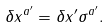Convert formula to latex. <formula><loc_0><loc_0><loc_500><loc_500>\delta x ^ { a ^ { \prime } } = \delta x ^ { \prime } \sigma ^ { a ^ { \prime } } .</formula> 